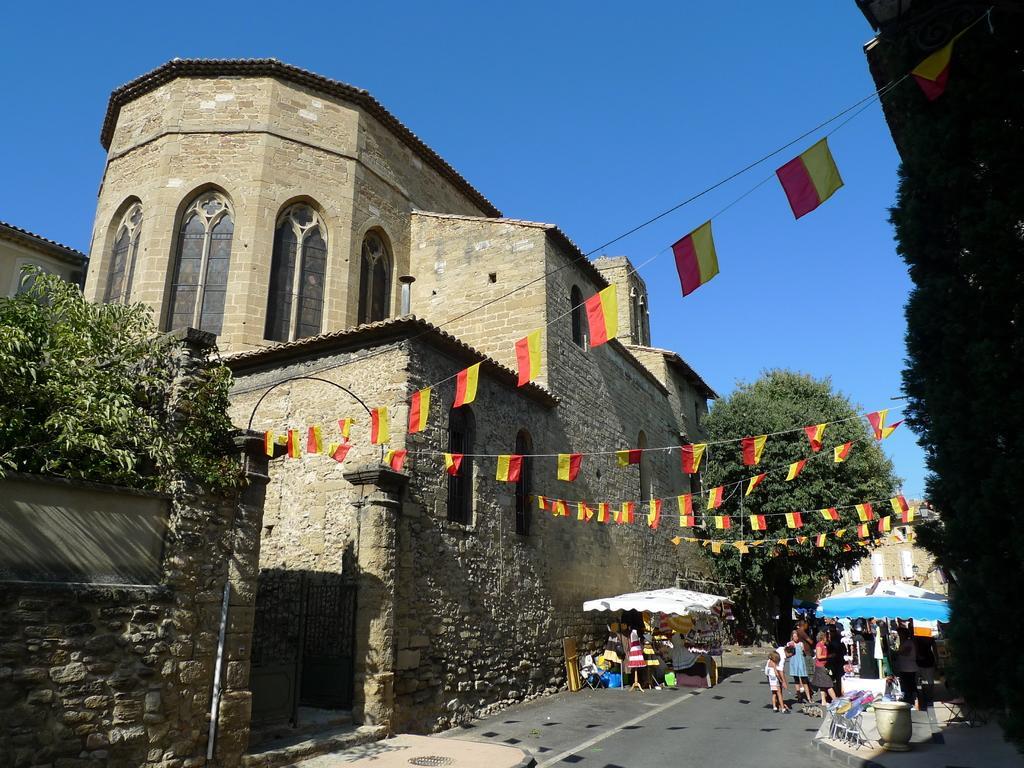Can you describe this image briefly? In this picture there are buildings and trees and there are tents and there are group of people standing on the road and there are objects and tables under the tents. There are flags on the ropes. At the top there is sky. At the bottom there is a road and there is a manhole. 